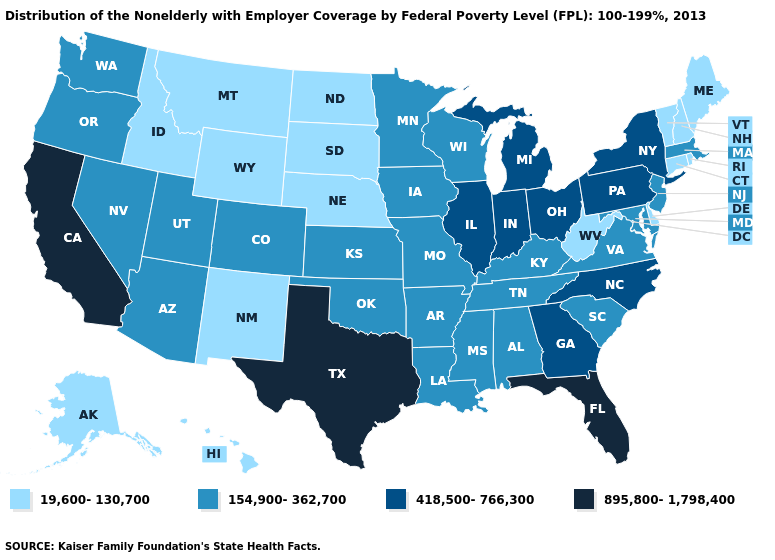What is the lowest value in states that border Virginia?
Keep it brief. 19,600-130,700. What is the lowest value in the USA?
Give a very brief answer. 19,600-130,700. Does Maine have the same value as Idaho?
Concise answer only. Yes. Name the states that have a value in the range 19,600-130,700?
Be succinct. Alaska, Connecticut, Delaware, Hawaii, Idaho, Maine, Montana, Nebraska, New Hampshire, New Mexico, North Dakota, Rhode Island, South Dakota, Vermont, West Virginia, Wyoming. What is the value of Michigan?
Quick response, please. 418,500-766,300. How many symbols are there in the legend?
Write a very short answer. 4. Does California have the highest value in the West?
Answer briefly. Yes. Does Wisconsin have the highest value in the MidWest?
Answer briefly. No. Which states have the lowest value in the West?
Be succinct. Alaska, Hawaii, Idaho, Montana, New Mexico, Wyoming. Name the states that have a value in the range 895,800-1,798,400?
Answer briefly. California, Florida, Texas. Does Illinois have a higher value than South Dakota?
Quick response, please. Yes. What is the highest value in the USA?
Be succinct. 895,800-1,798,400. Which states have the lowest value in the USA?
Answer briefly. Alaska, Connecticut, Delaware, Hawaii, Idaho, Maine, Montana, Nebraska, New Hampshire, New Mexico, North Dakota, Rhode Island, South Dakota, Vermont, West Virginia, Wyoming. Name the states that have a value in the range 418,500-766,300?
Concise answer only. Georgia, Illinois, Indiana, Michigan, New York, North Carolina, Ohio, Pennsylvania. 